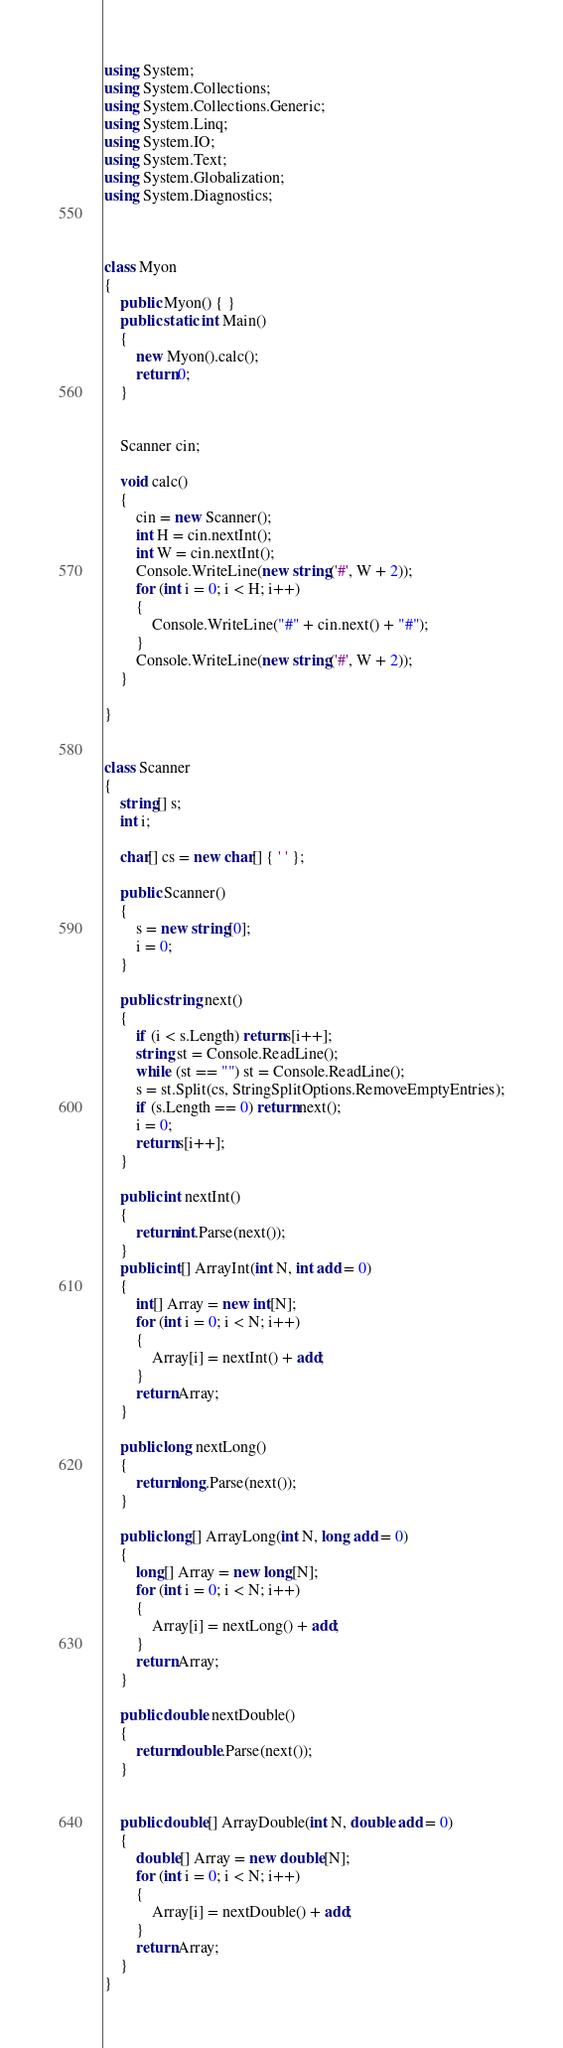<code> <loc_0><loc_0><loc_500><loc_500><_C#_>using System;
using System.Collections;
using System.Collections.Generic;
using System.Linq;
using System.IO;
using System.Text;
using System.Globalization;
using System.Diagnostics;



class Myon
{
    public Myon() { }
    public static int Main()
    {
        new Myon().calc();
        return 0;
    }


    Scanner cin;

    void calc()
    {
        cin = new Scanner();
        int H = cin.nextInt();
        int W = cin.nextInt();
        Console.WriteLine(new string('#', W + 2));
        for (int i = 0; i < H; i++)
        {
            Console.WriteLine("#" + cin.next() + "#");
        }
        Console.WriteLine(new string('#', W + 2));
    }

}


class Scanner
{
    string[] s;
    int i;

    char[] cs = new char[] { ' ' };

    public Scanner()
    {
        s = new string[0];
        i = 0;
    }

    public string next()
    {
        if (i < s.Length) return s[i++];
        string st = Console.ReadLine();
        while (st == "") st = Console.ReadLine();
        s = st.Split(cs, StringSplitOptions.RemoveEmptyEntries);
        if (s.Length == 0) return next();
        i = 0;
        return s[i++];
    }

    public int nextInt()
    {
        return int.Parse(next());
    }
    public int[] ArrayInt(int N, int add = 0)
    {
        int[] Array = new int[N];
        for (int i = 0; i < N; i++)
        {
            Array[i] = nextInt() + add;
        }
        return Array;
    }

    public long nextLong()
    {
        return long.Parse(next());
    }

    public long[] ArrayLong(int N, long add = 0)
    {
        long[] Array = new long[N];
        for (int i = 0; i < N; i++)
        {
            Array[i] = nextLong() + add;
        }
        return Array;
    }

    public double nextDouble()
    {
        return double.Parse(next());
    }


    public double[] ArrayDouble(int N, double add = 0)
    {
        double[] Array = new double[N];
        for (int i = 0; i < N; i++)
        {
            Array[i] = nextDouble() + add;
        }
        return Array;
    }
}
</code> 